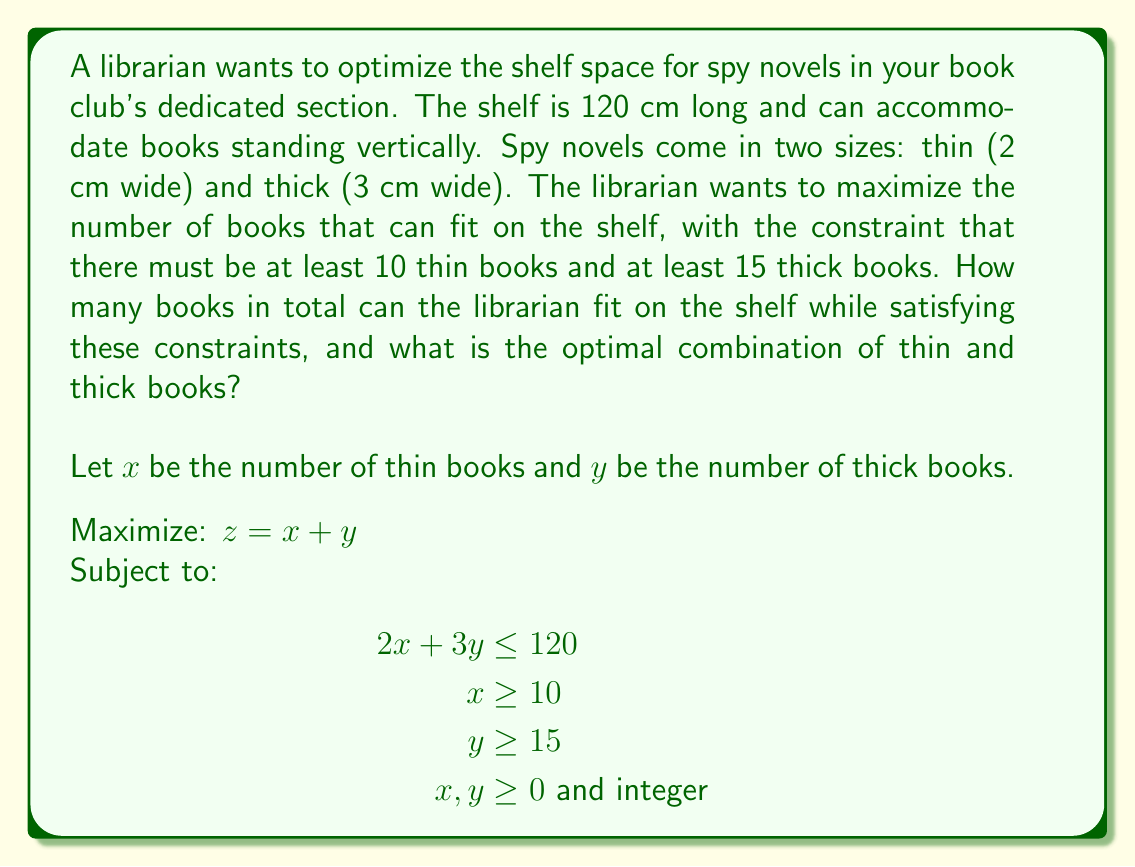Can you answer this question? To solve this linear programming problem with integer constraints, we'll follow these steps:

1) First, let's graph the constraints:
   $2x + 3y \leq 120$ (shelf space constraint)
   $x \geq 10$ (minimum thin books)
   $y \geq 15$ (minimum thick books)

2) The feasible region is the area that satisfies all these constraints.

3) We know that the optimal solution will be at one of the corner points of this feasible region.

4) The corner points are:
   (10, 33.33), (30, 20), (60, 0)

5) However, we need integer solutions. So we'll check the integer points near these corners:
   (10, 33), (10, 34), (30, 20), (31, 19)

6) Let's evaluate our objective function $z = x + y$ at each of these points:
   (10, 33): $z = 10 + 33 = 43$
   (10, 34): $z = 10 + 34 = 44$ (but this violates the shelf space constraint)
   (30, 20): $z = 30 + 20 = 50$
   (31, 19): $z = 31 + 19 = 50$

7) The maximum value of $z$ that satisfies all constraints is 50.

Therefore, the optimal solution is to have either 30 thin books and 20 thick books, or 31 thin books and 19 thick books. Both combinations result in a total of 50 books.
Answer: The librarian can fit a maximum of 50 spy novels on the shelf. The optimal combination is either 30 thin books and 20 thick books, or 31 thin books and 19 thick books. 